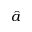Convert formula to latex. <formula><loc_0><loc_0><loc_500><loc_500>\hat { a }</formula> 